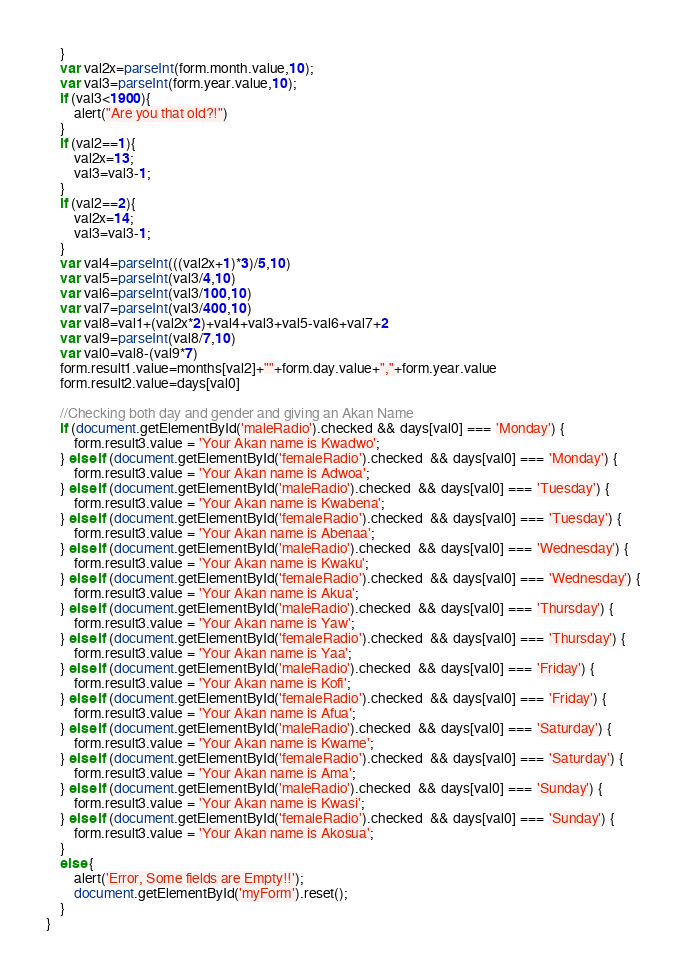<code> <loc_0><loc_0><loc_500><loc_500><_JavaScript_>    }
    var val2x=parseInt(form.month.value,10);
    var val3=parseInt(form.year.value,10);
    if (val3<1900){
        alert("Are you that old?!")
    }
    if (val2==1){
        val2x=13;
        val3=val3-1;
    }
    if (val2==2){
        val2x=14;
        val3=val3-1;
    }
    var val4=parseInt(((val2x+1)*3)/5,10)
    var val5=parseInt(val3/4,10)
    var val6=parseInt(val3/100,10)
    var val7=parseInt(val3/400,10)
    var val8=val1+(val2x*2)+val4+val3+val5-val6+val7+2
    var val9=parseInt(val8/7,10)
    var val0=val8-(val9*7)
    form.result1.value=months[val2]+""+form.day.value+","+form.year.value
    form.result2.value=days[val0]

    //Checking both day and gender and giving an Akan Name
    if (document.getElementById('maleRadio').checked && days[val0] === 'Monday') {
        form.result3.value = 'Your Akan name is Kwadwo';
    } else if (document.getElementById('femaleRadio').checked  && days[val0] === 'Monday') {
        form.result3.value = 'Your Akan name is Adwoa';
    } else if (document.getElementById('maleRadio').checked  && days[val0] === 'Tuesday') {
        form.result3.value = 'Your Akan name is Kwabena';
    } else if (document.getElementById('femaleRadio').checked  && days[val0] === 'Tuesday') {
        form.result3.value = 'Your Akan name is Abenaa';
    } else if (document.getElementById('maleRadio').checked  && days[val0] === 'Wednesday') {
        form.result3.value = 'Your Akan name is Kwaku';
    } else if (document.getElementById('femaleRadio').checked  && days[val0] === 'Wednesday') {
        form.result3.value = 'Your Akan name is Akua';
    } else if (document.getElementById('maleRadio').checked  && days[val0] === 'Thursday') {
        form.result3.value = 'Your Akan name is Yaw';
    } else if (document.getElementById('femaleRadio').checked  && days[val0] === 'Thursday') {
        form.result3.value = 'Your Akan name is Yaa';
    } else if (document.getElementById('maleRadio').checked  && days[val0] === 'Friday') {
        form.result3.value = 'Your Akan name is Kofi';
    } else if (document.getElementById('femaleRadio').checked  && days[val0] === 'Friday') {
        form.result3.value = 'Your Akan name is Afua';
    } else if (document.getElementById('maleRadio').checked  && days[val0] === 'Saturday') {
        form.result3.value = 'Your Akan name is Kwame';
    } else if (document.getElementById('femaleRadio').checked  && days[val0] === 'Saturday') {
        form.result3.value = 'Your Akan name is Ama';
    } else if (document.getElementById('maleRadio').checked  && days[val0] === 'Sunday') {
        form.result3.value = 'Your Akan name is Kwasi';
    } else if (document.getElementById('femaleRadio').checked  && days[val0] === 'Sunday') {
        form.result3.value = 'Your Akan name is Akosua';
    }
    else {
        alert('Error, Some fields are Empty!!');
        document.getElementById('myForm').reset();
    }
}</code> 